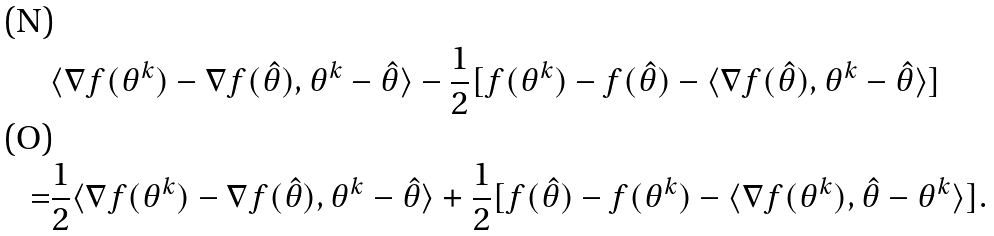<formula> <loc_0><loc_0><loc_500><loc_500>& \langle \nabla f ( \theta ^ { k } ) - \nabla f ( \hat { \theta } ) , \theta ^ { k } - \hat { \theta } \rangle - \frac { 1 } { 2 } [ f ( \theta ^ { k } ) - f ( \hat { \theta } ) - \langle \nabla f ( \hat { \theta } ) , \theta ^ { k } - \hat { \theta } \rangle ] \\ = & \frac { 1 } { 2 } \langle \nabla f ( \theta ^ { k } ) - \nabla f ( \hat { \theta } ) , \theta ^ { k } - \hat { \theta } \rangle + \frac { 1 } { 2 } [ f ( \hat { \theta } ) - f ( \theta ^ { k } ) - \langle \nabla f ( \theta ^ { k } ) , \hat { \theta } - \theta ^ { k } \rangle ] .</formula> 